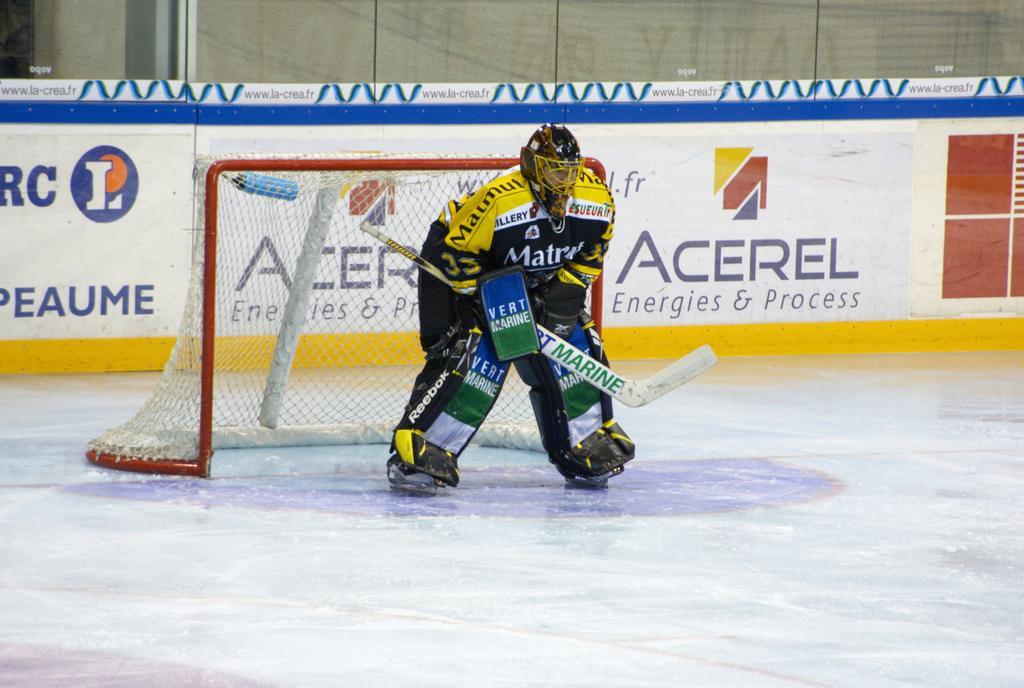In one or two sentences, can you explain what this image depicts? In this image we can see a person standing on the ground wearing a helmet and a knee pad holding a bat. We can also see a goal post, a board with some text on it and a wall. 